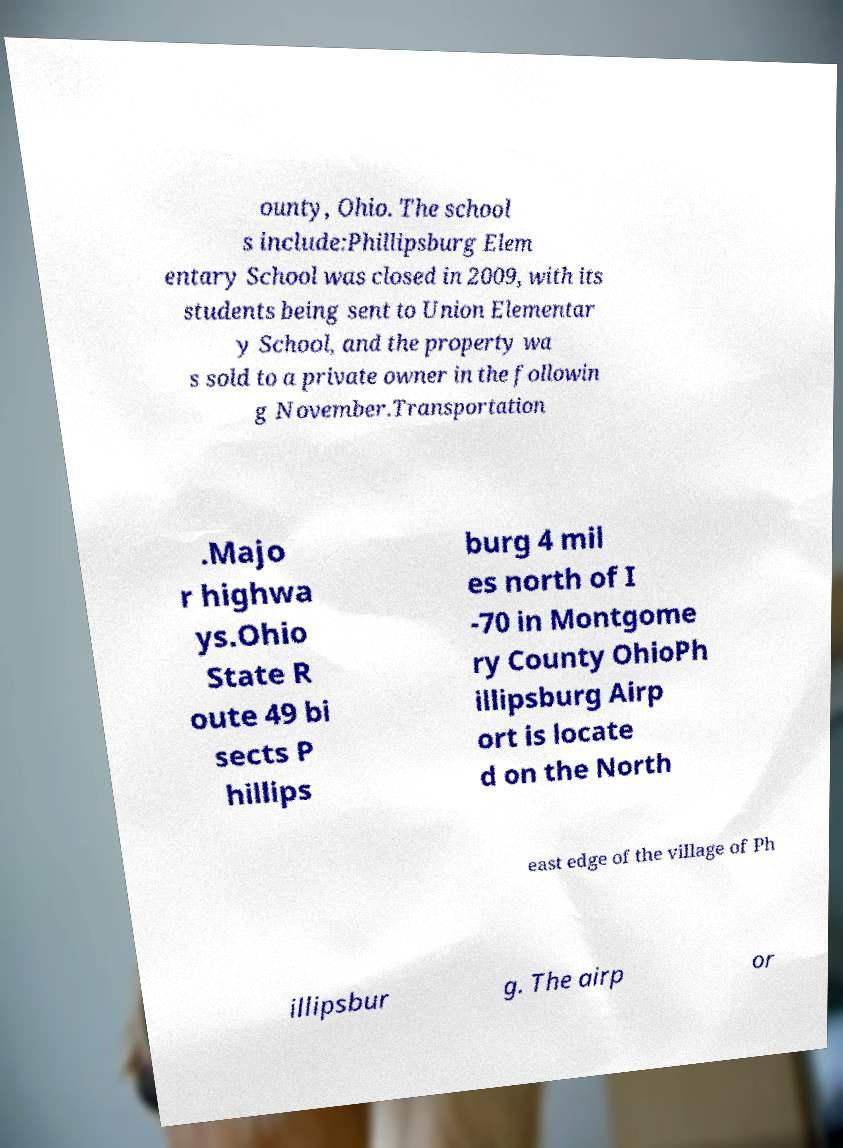Could you assist in decoding the text presented in this image and type it out clearly? ounty, Ohio. The school s include:Phillipsburg Elem entary School was closed in 2009, with its students being sent to Union Elementar y School, and the property wa s sold to a private owner in the followin g November.Transportation .Majo r highwa ys.Ohio State R oute 49 bi sects P hillips burg 4 mil es north of I -70 in Montgome ry County OhioPh illipsburg Airp ort is locate d on the North east edge of the village of Ph illipsbur g. The airp or 